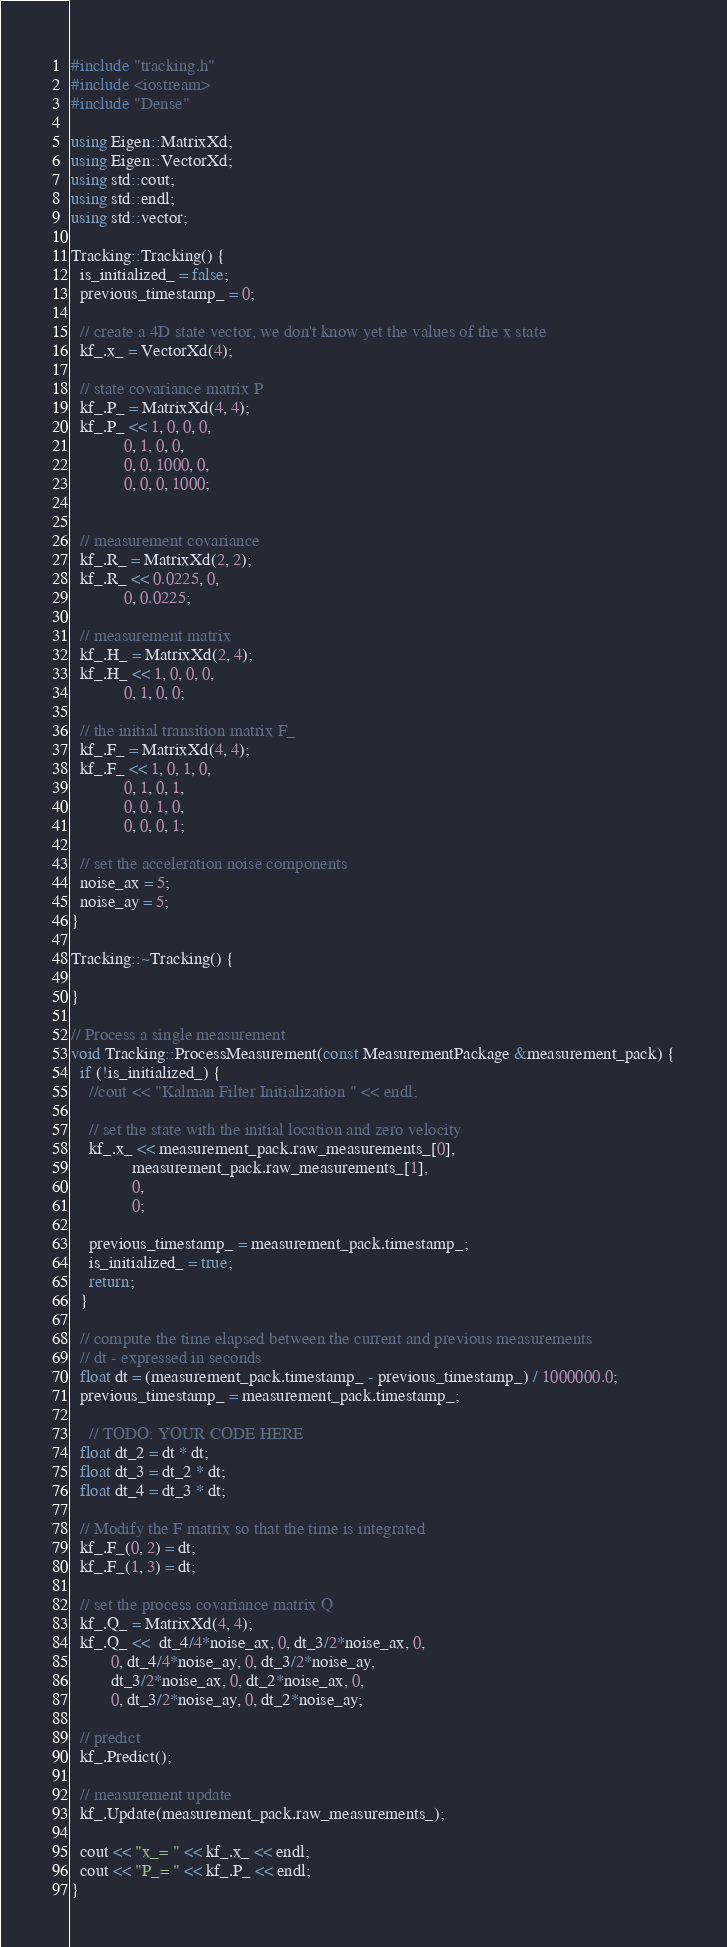Convert code to text. <code><loc_0><loc_0><loc_500><loc_500><_C++_>#include "tracking.h"
#include <iostream>
#include "Dense"

using Eigen::MatrixXd;
using Eigen::VectorXd;
using std::cout;
using std::endl;
using std::vector;

Tracking::Tracking() {
  is_initialized_ = false;
  previous_timestamp_ = 0;

  // create a 4D state vector, we don't know yet the values of the x state
  kf_.x_ = VectorXd(4);

  // state covariance matrix P
  kf_.P_ = MatrixXd(4, 4);
  kf_.P_ << 1, 0, 0, 0,
            0, 1, 0, 0,
            0, 0, 1000, 0,
            0, 0, 0, 1000;


  // measurement covariance
  kf_.R_ = MatrixXd(2, 2);
  kf_.R_ << 0.0225, 0,
            0, 0.0225;

  // measurement matrix
  kf_.H_ = MatrixXd(2, 4);
  kf_.H_ << 1, 0, 0, 0,
            0, 1, 0, 0;

  // the initial transition matrix F_
  kf_.F_ = MatrixXd(4, 4);
  kf_.F_ << 1, 0, 1, 0,
            0, 1, 0, 1,
            0, 0, 1, 0,
            0, 0, 0, 1;

  // set the acceleration noise components
  noise_ax = 5;
  noise_ay = 5;
}

Tracking::~Tracking() {

}

// Process a single measurement
void Tracking::ProcessMeasurement(const MeasurementPackage &measurement_pack) {
  if (!is_initialized_) {
    //cout << "Kalman Filter Initialization " << endl;

    // set the state with the initial location and zero velocity
    kf_.x_ << measurement_pack.raw_measurements_[0], 
              measurement_pack.raw_measurements_[1], 
              0, 
              0;

    previous_timestamp_ = measurement_pack.timestamp_;
    is_initialized_ = true;
    return;
  }

  // compute the time elapsed between the current and previous measurements
  // dt - expressed in seconds
  float dt = (measurement_pack.timestamp_ - previous_timestamp_) / 1000000.0;
  previous_timestamp_ = measurement_pack.timestamp_;
  
    // TODO: YOUR CODE HERE
  float dt_2 = dt * dt;
  float dt_3 = dt_2 * dt;
  float dt_4 = dt_3 * dt;

  // Modify the F matrix so that the time is integrated
  kf_.F_(0, 2) = dt;
  kf_.F_(1, 3) = dt;

  // set the process covariance matrix Q
  kf_.Q_ = MatrixXd(4, 4);
  kf_.Q_ <<  dt_4/4*noise_ax, 0, dt_3/2*noise_ax, 0,
         0, dt_4/4*noise_ay, 0, dt_3/2*noise_ay,
         dt_3/2*noise_ax, 0, dt_2*noise_ax, 0,
         0, dt_3/2*noise_ay, 0, dt_2*noise_ay;

  // predict
  kf_.Predict();

  // measurement update
  kf_.Update(measurement_pack.raw_measurements_);
  
  cout << "x_= " << kf_.x_ << endl;
  cout << "P_= " << kf_.P_ << endl;
}</code> 